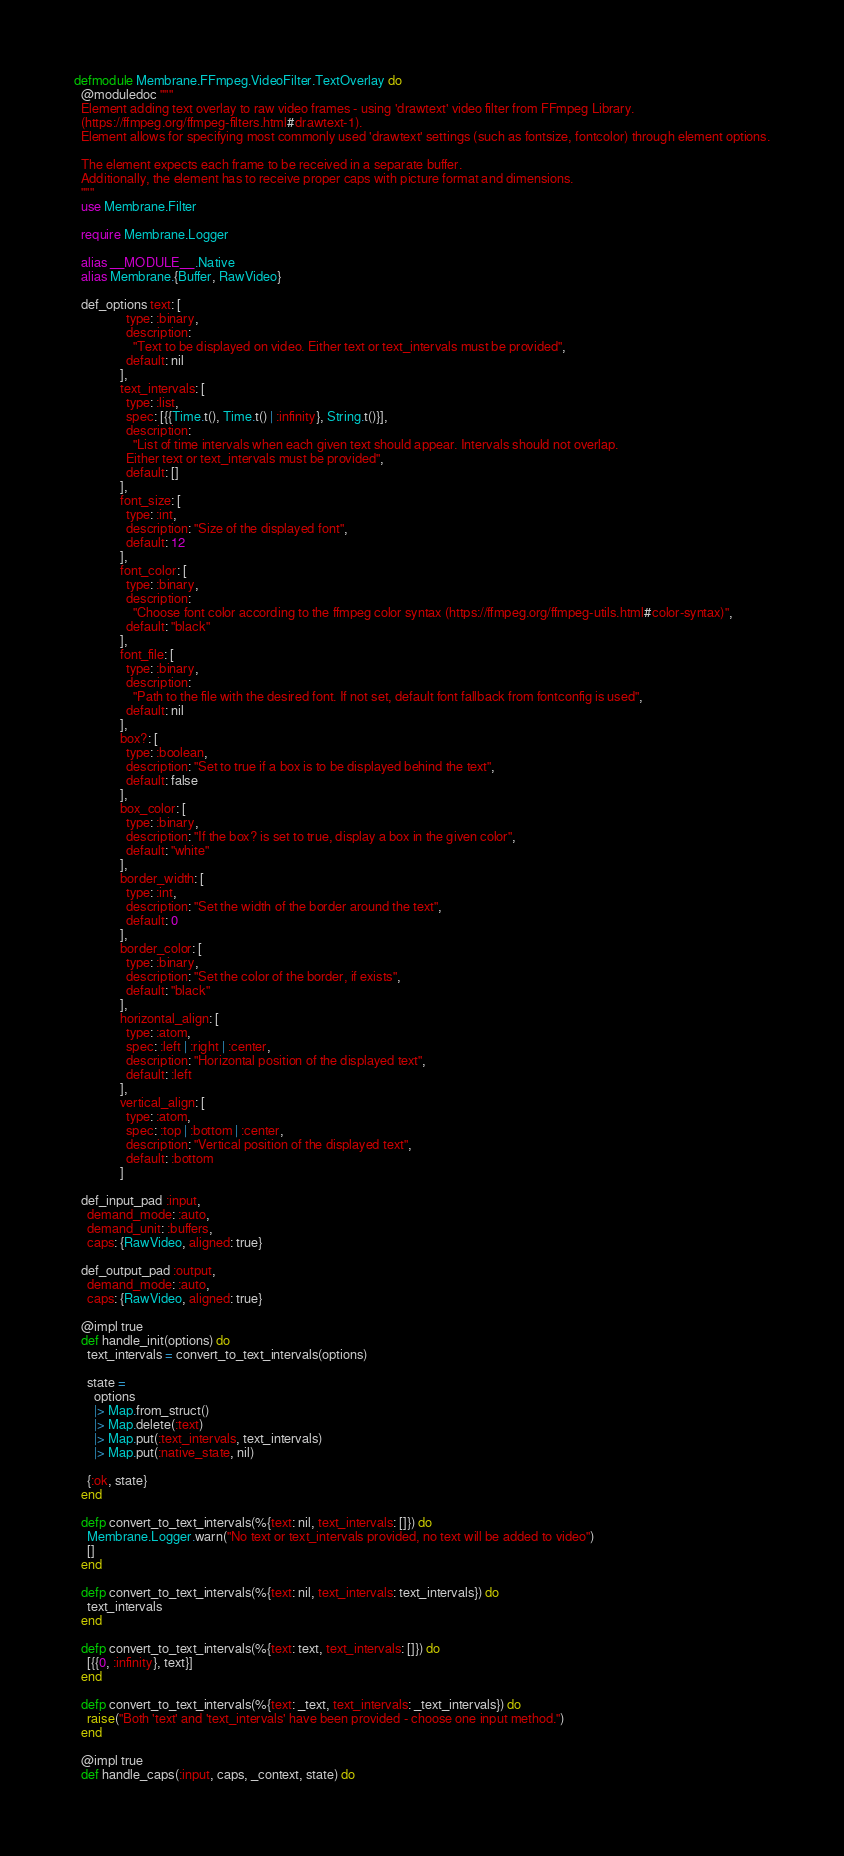<code> <loc_0><loc_0><loc_500><loc_500><_Elixir_>defmodule Membrane.FFmpeg.VideoFilter.TextOverlay do
  @moduledoc """
  Element adding text overlay to raw video frames - using 'drawtext' video filter from FFmpeg Library.
  (https://ffmpeg.org/ffmpeg-filters.html#drawtext-1).
  Element allows for specifying most commonly used 'drawtext' settings (such as fontsize, fontcolor) through element options.

  The element expects each frame to be received in a separate buffer.
  Additionally, the element has to receive proper caps with picture format and dimensions.
  """
  use Membrane.Filter

  require Membrane.Logger

  alias __MODULE__.Native
  alias Membrane.{Buffer, RawVideo}

  def_options text: [
                type: :binary,
                description:
                  "Text to be displayed on video. Either text or text_intervals must be provided",
                default: nil
              ],
              text_intervals: [
                type: :list,
                spec: [{{Time.t(), Time.t() | :infinity}, String.t()}],
                description:
                  "List of time intervals when each given text should appear. Intervals should not overlap.
                Either text or text_intervals must be provided",
                default: []
              ],
              font_size: [
                type: :int,
                description: "Size of the displayed font",
                default: 12
              ],
              font_color: [
                type: :binary,
                description:
                  "Choose font color according to the ffmpeg color syntax (https://ffmpeg.org/ffmpeg-utils.html#color-syntax)",
                default: "black"
              ],
              font_file: [
                type: :binary,
                description:
                  "Path to the file with the desired font. If not set, default font fallback from fontconfig is used",
                default: nil
              ],
              box?: [
                type: :boolean,
                description: "Set to true if a box is to be displayed behind the text",
                default: false
              ],
              box_color: [
                type: :binary,
                description: "If the box? is set to true, display a box in the given color",
                default: "white"
              ],
              border_width: [
                type: :int,
                description: "Set the width of the border around the text",
                default: 0
              ],
              border_color: [
                type: :binary,
                description: "Set the color of the border, if exists",
                default: "black"
              ],
              horizontal_align: [
                type: :atom,
                spec: :left | :right | :center,
                description: "Horizontal position of the displayed text",
                default: :left
              ],
              vertical_align: [
                type: :atom,
                spec: :top | :bottom | :center,
                description: "Vertical position of the displayed text",
                default: :bottom
              ]

  def_input_pad :input,
    demand_mode: :auto,
    demand_unit: :buffers,
    caps: {RawVideo, aligned: true}

  def_output_pad :output,
    demand_mode: :auto,
    caps: {RawVideo, aligned: true}

  @impl true
  def handle_init(options) do
    text_intervals = convert_to_text_intervals(options)

    state =
      options
      |> Map.from_struct()
      |> Map.delete(:text)
      |> Map.put(:text_intervals, text_intervals)
      |> Map.put(:native_state, nil)

    {:ok, state}
  end

  defp convert_to_text_intervals(%{text: nil, text_intervals: []}) do
    Membrane.Logger.warn("No text or text_intervals provided, no text will be added to video")
    []
  end

  defp convert_to_text_intervals(%{text: nil, text_intervals: text_intervals}) do
    text_intervals
  end

  defp convert_to_text_intervals(%{text: text, text_intervals: []}) do
    [{{0, :infinity}, text}]
  end

  defp convert_to_text_intervals(%{text: _text, text_intervals: _text_intervals}) do
    raise("Both 'text' and 'text_intervals' have been provided - choose one input method.")
  end

  @impl true
  def handle_caps(:input, caps, _context, state) do</code> 